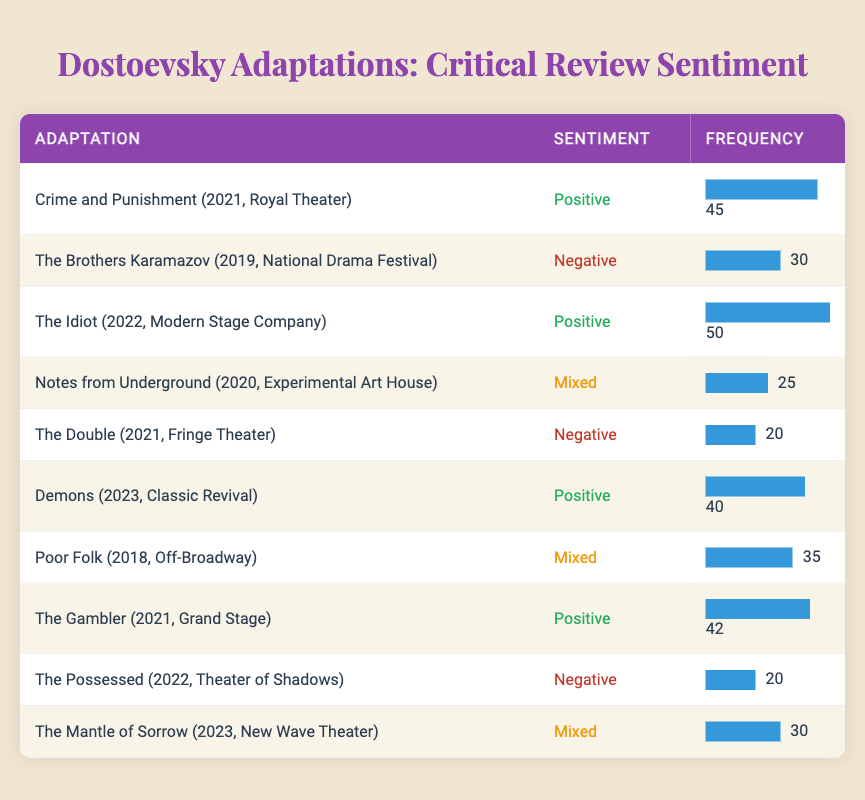What is the highest frequency of reviews among the adaptations? The adaptation with the highest frequency is "The Idiot (2022, Modern Stage Company)" with a frequency of 50. We can find this by scanning through the frequency column to identify the maximum value.
Answer: 50 How many adaptations received positive sentiments? To determine how many adaptations received positive sentiments, we can count the rows where the sentiment is labeled as "Positive." There are four adaptations with positive sentiments: "Crime and Punishment," "The Idiot," "Demons," and "The Gambler." Therefore, the count is 4.
Answer: 4 What is the total frequency of adaptations that received negative reviews? The total frequency for negative reviews is calculated by adding the frequencies of the negative adaptations: "The Brothers Karamazov" (30) + "The Double" (20) + "The Possessed" (20) = 70. Thus, the sum of negative frequencies is 70.
Answer: 70 Is "Notes from Underground" the only adaptation with mixed reviews? No, there are three adaptations that received mixed reviews: "Notes from Underground," "Poor Folk," and "The Mantle of Sorrow." Thus, it is incorrect to say that "Notes from Underground" is the only one with mixed reviews.
Answer: No What’s the average frequency of adaptations that received mixed reviews? To find the average frequency, we first sum the frequencies for the mixed reviews: "Notes from Underground" (25), "Poor Folk" (35), and "The Mantle of Sorrow" (30), which equals 90. Then we divide by the number of mixed reviews, which is 3. Thus, the average frequency is 90 / 3 = 30.
Answer: 30 